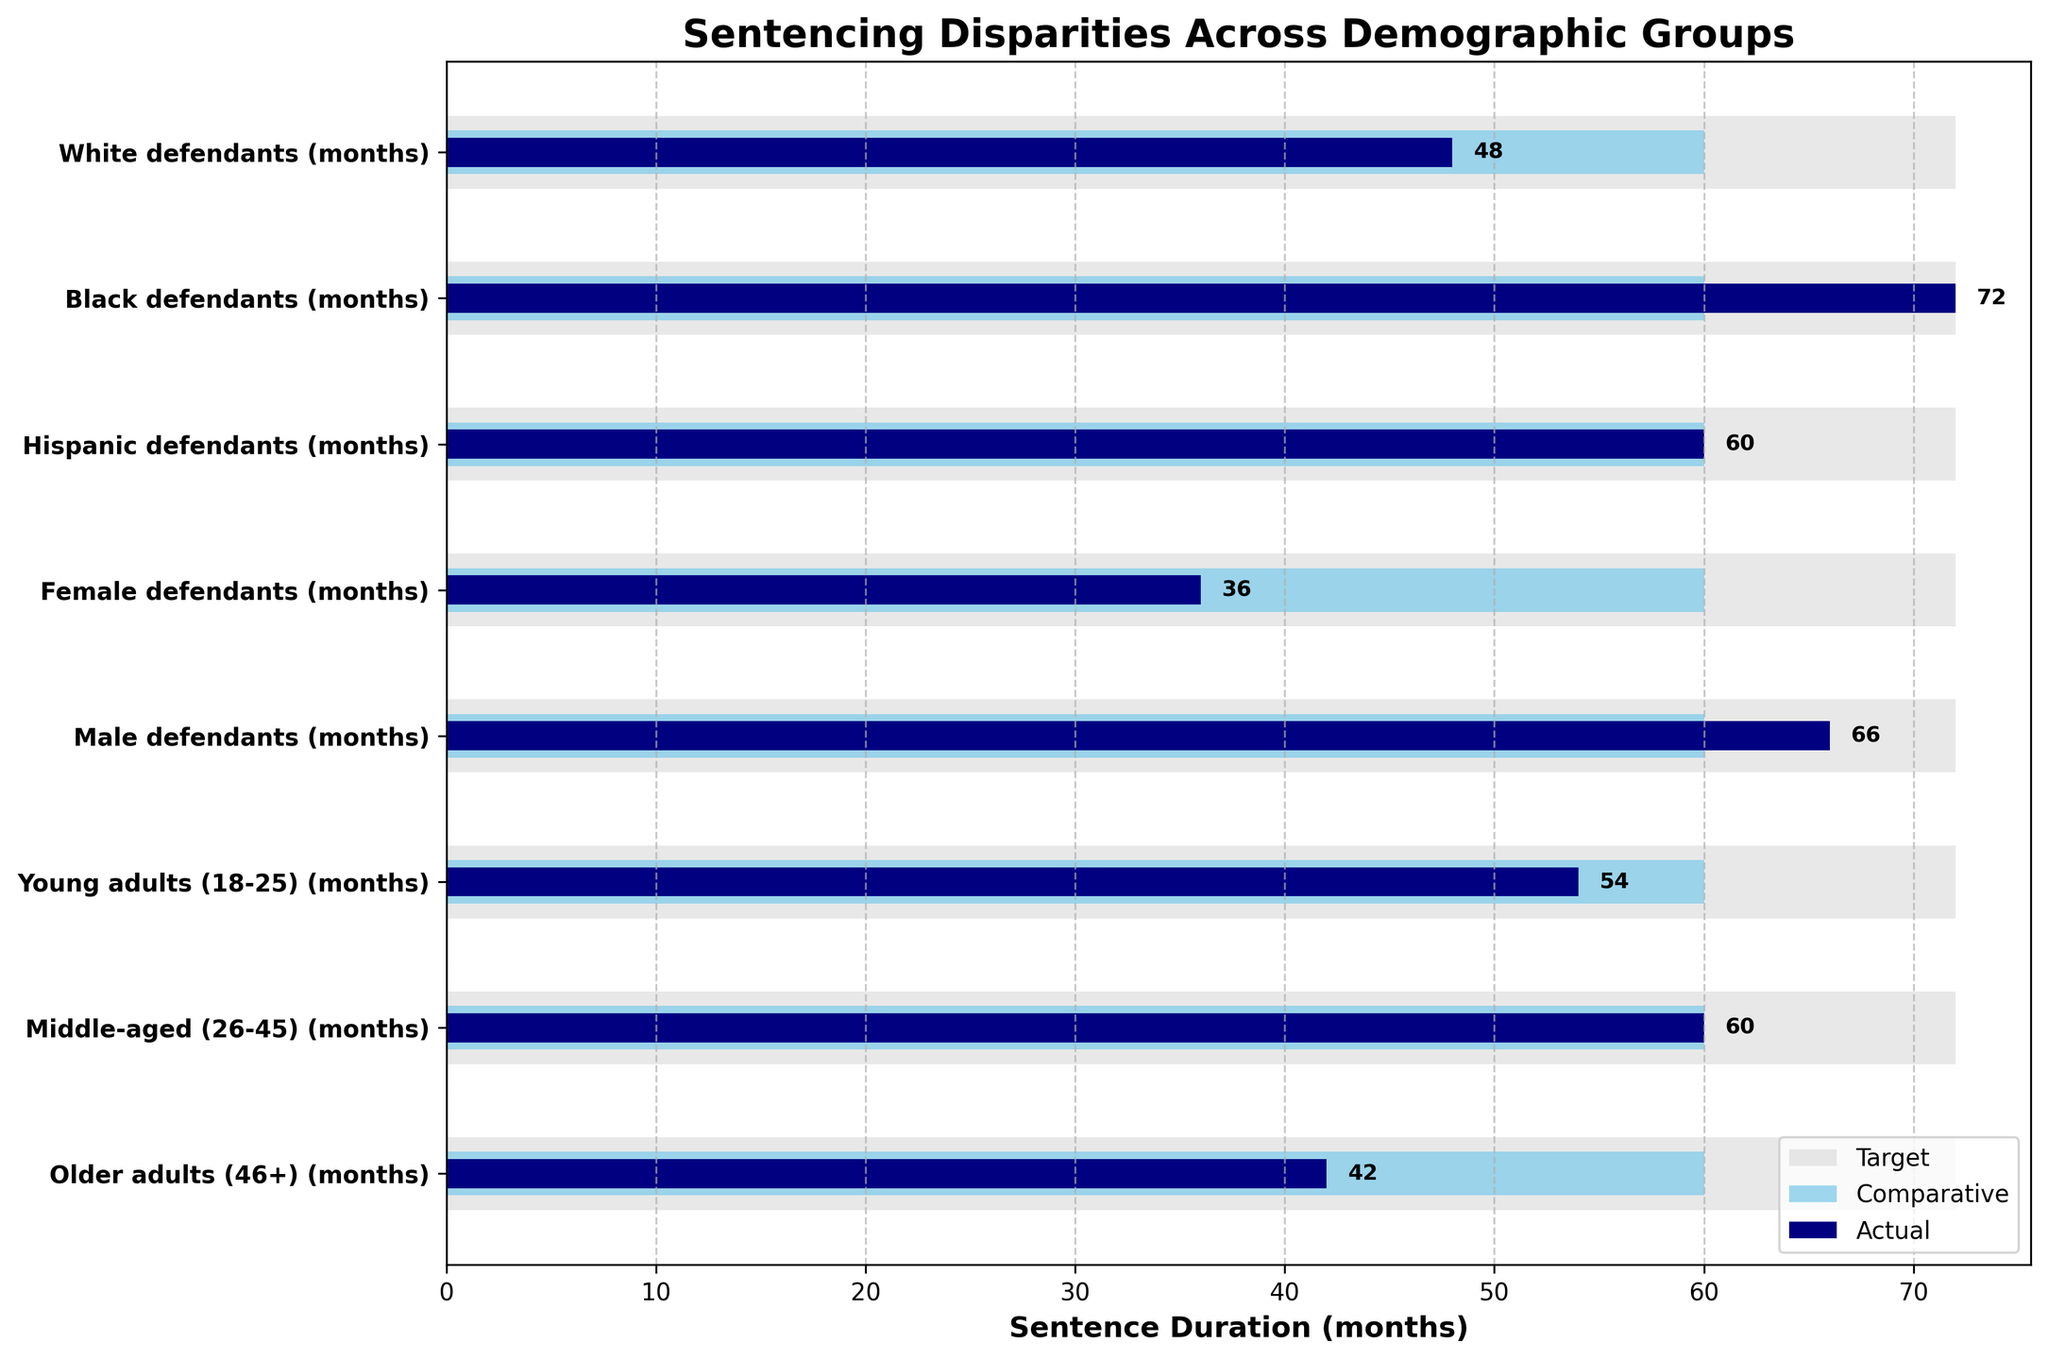What is the title of the figure? The title is typically found at the top of the chart, and it describes what the figure represents. In this case, it is "Sentencing Disparities Across Demographic Groups".
Answer: Sentencing Disparities Across Demographic Groups What are the categories listed on the y-axis? The categories on the y-axis can be read from top to bottom and include different demographic groups related to the sentencing disparities being measured. These are "White defendants (months)", "Black defendants (months)", "Hispanic defendants (months)", "Female defendants (months)", "Male defendants (months)", "Young adults (18-25) (months)", "Middle-aged (26-45) (months)", and "Older adults (46+) (months)".
Answer: White defendants, Black defendants, Hispanic defendants, Female defendants, Male defendants, Young adults (18-25), Middle-aged (26-45), Older adults (46+) Which demographic group has the highest actual sentence duration? To find the group with the highest actual sentence duration, examine the 'Actual' bars and identify the longest one. The group with the highest value for the 'Actual' sentence is "Black defendants (72 months)".
Answer: Black defendants How does the actual sentence duration for female defendants compare to the target sentence? The actual sentence duration for female defendants is shorter than the target sentence. By looking at the length of the bars, the actual duration is 36 months while the target is 72 months.
Answer: Shorter What is the difference between the actual and comparative sentence durations for male defendants? Identify the lengths of the 'Actual' and 'Comparative' bars for male defendants. The actual sentence duration is 66 months, and the comparative duration is 60 months. Subtract the comparative value from the actual value: 66 - 60 = 6 months.
Answer: 6 months Which group’s actual sentence duration exactly matches the comparative sentence duration? This requires identifying the group where the 'Actual' and 'Comparative' bars are of equal length. The group where these values match is "Hispanic defendants (60 months)".
Answer: Hispanic defendants For which demographic group is the target sentence duration greater than both the actual and comparative durations? Analyze the figure and select the group where the target duration is longer than both the actual and comparative durations. The target (72 months) is greater than the actual (48 months) and comparative (60 months) for "White defendants".
Answer: White defendants How many months more are younger adults (18-25) sentenced compared to older adults (46+) in terms of actual sentence duration? Compare the 'Actual' sentence bars for "Young adults (54 months)" and "Older adults (42 months)". Calculate the difference: 54 - 42 = 12 months.
Answer: 12 months What can you infer about sentencing disparities based on gender (male vs. female)? Compare the 'Actual', 'Comparative', and 'Target' bars for male and female defendants. Male defendants have a higher actual sentence duration (66 months) compared to female defendants (36 months).
Answer: Male defendants have longer sentences than female defendants Which demographic group falls short of the comparative duration the most in actual sentence duration? Identify the group with the largest difference where the actual duration is less than the comparative duration. "Female defendants" have the largest shortfall: Comparative (60 months) - Actual (36 months) = 24 months.
Answer: Female defendants 